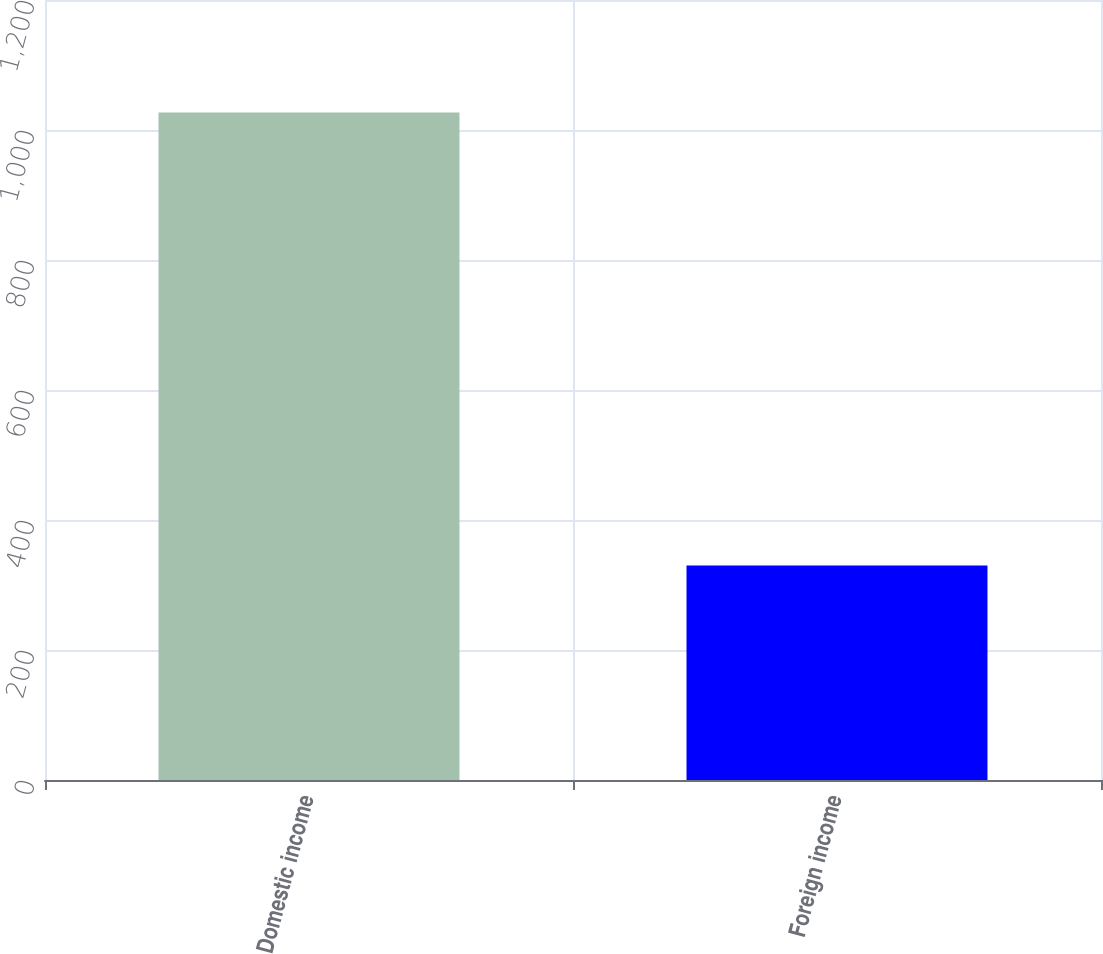Convert chart. <chart><loc_0><loc_0><loc_500><loc_500><bar_chart><fcel>Domestic income<fcel>Foreign income<nl><fcel>1027<fcel>330<nl></chart> 